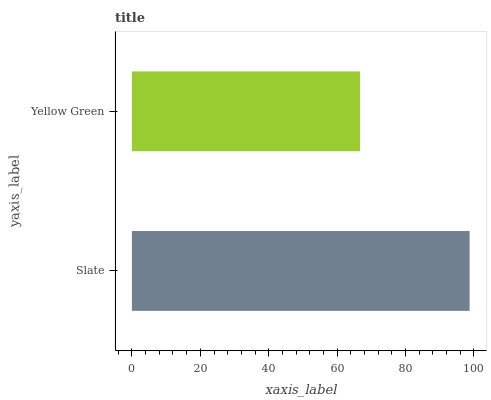Is Yellow Green the minimum?
Answer yes or no. Yes. Is Slate the maximum?
Answer yes or no. Yes. Is Yellow Green the maximum?
Answer yes or no. No. Is Slate greater than Yellow Green?
Answer yes or no. Yes. Is Yellow Green less than Slate?
Answer yes or no. Yes. Is Yellow Green greater than Slate?
Answer yes or no. No. Is Slate less than Yellow Green?
Answer yes or no. No. Is Slate the high median?
Answer yes or no. Yes. Is Yellow Green the low median?
Answer yes or no. Yes. Is Yellow Green the high median?
Answer yes or no. No. Is Slate the low median?
Answer yes or no. No. 